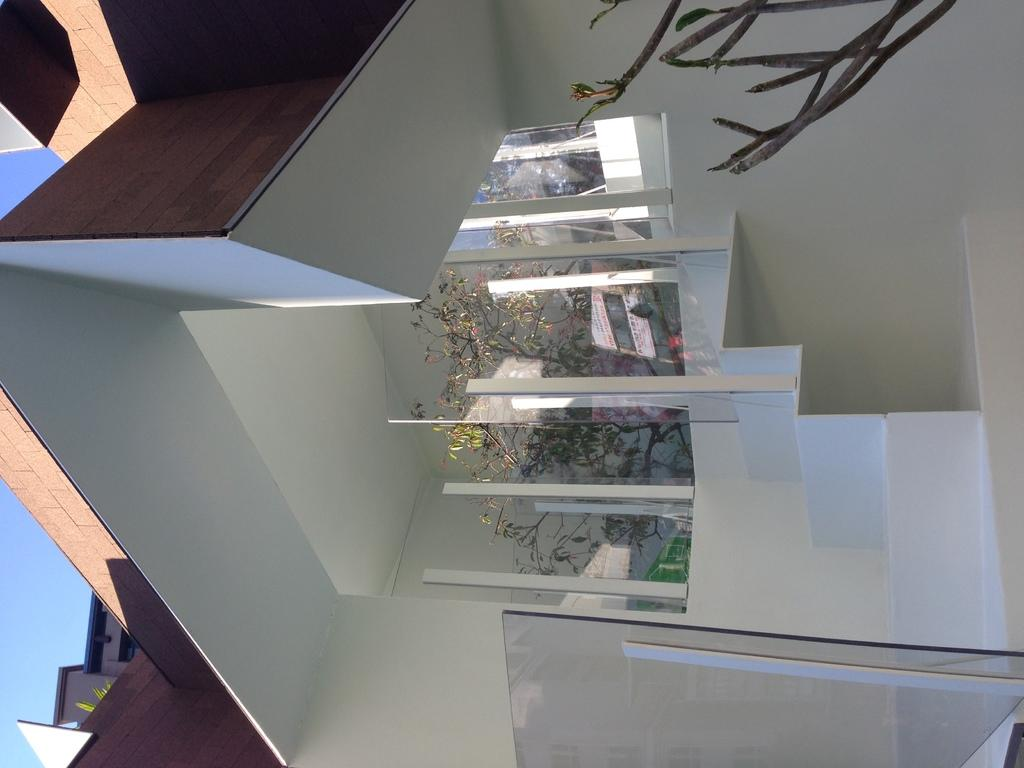What type of outdoor space is visible in the image? There is a porch in the image. To which structure does the porch belong? The porch belongs to a building. What can be seen on the porch? There are trees present on the porch. What type of stream can be seen flowing through the porch in the image? There is no stream present in the image; it features a porch with trees. 